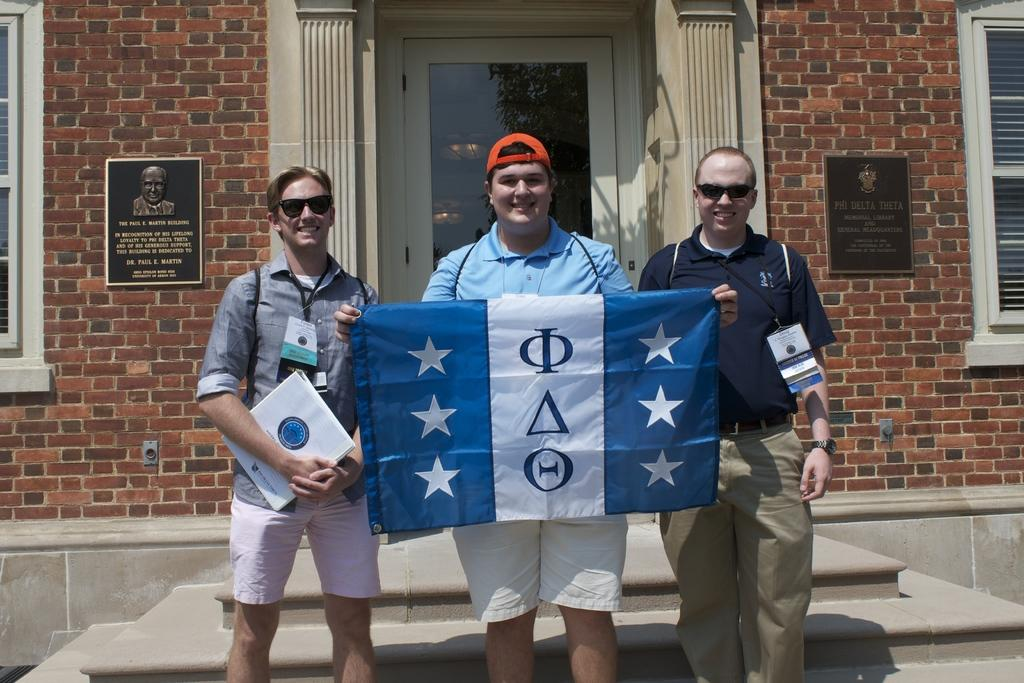What is the person on the left side of the image holding? The person on the left side of the image is holding a book. What is the person on the right side of the image holding? The person on the right side of the image is holding cloth. What type of structure can be seen in the image? There is a well in the image. What architectural feature is present in the image? There is a door and a wall in the image. What type of square object can be seen in the drawer in the image? There is no drawer or square object present in the image. 